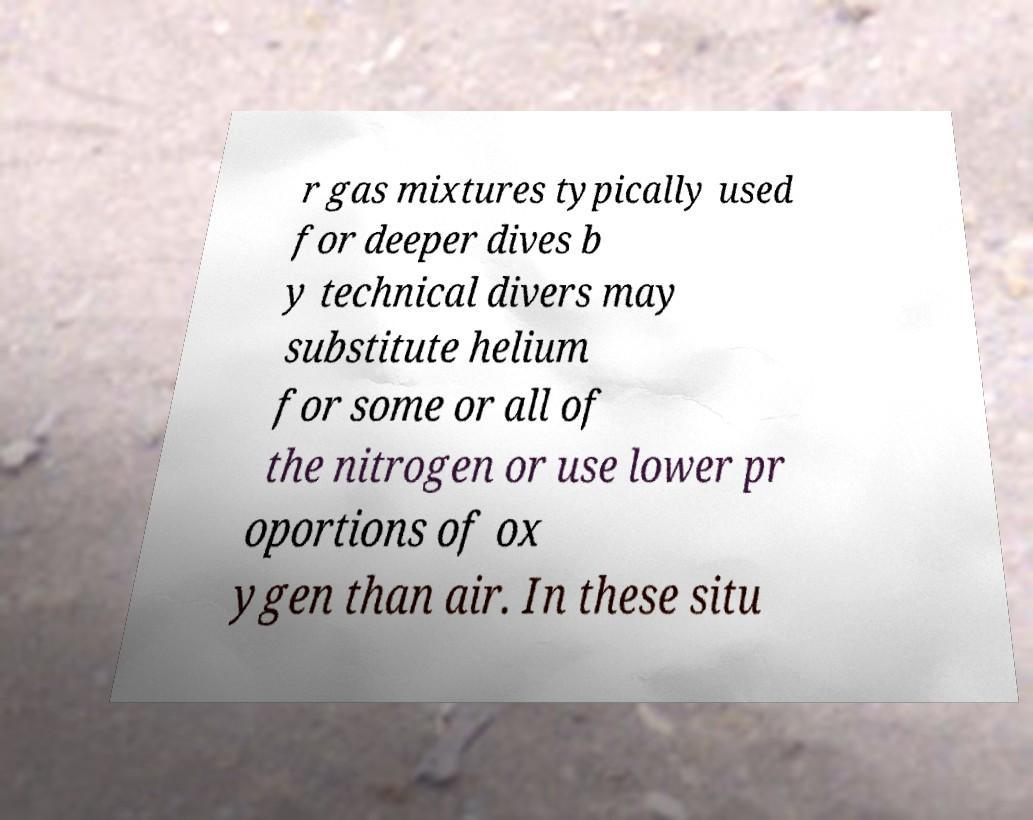Could you assist in decoding the text presented in this image and type it out clearly? r gas mixtures typically used for deeper dives b y technical divers may substitute helium for some or all of the nitrogen or use lower pr oportions of ox ygen than air. In these situ 